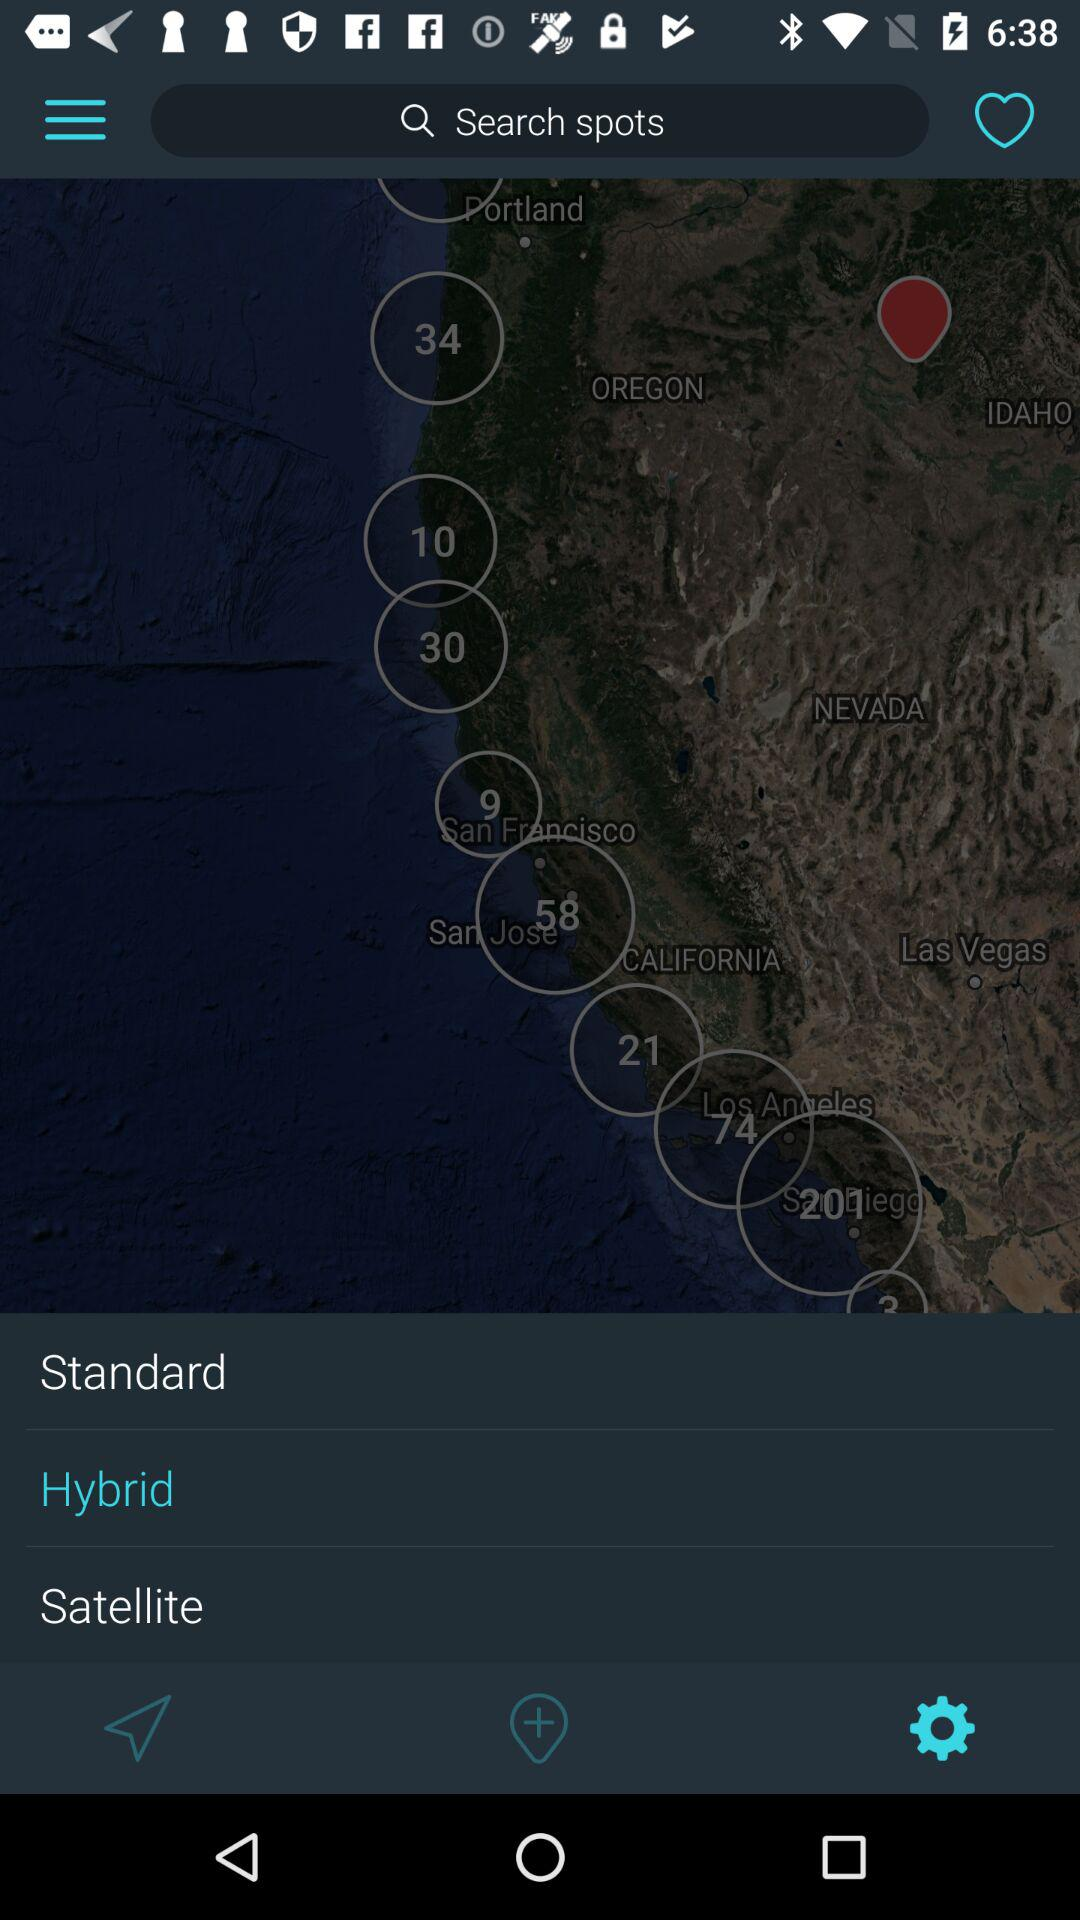Which type of map view is selected? The selected type of map view is "Hybrid". 